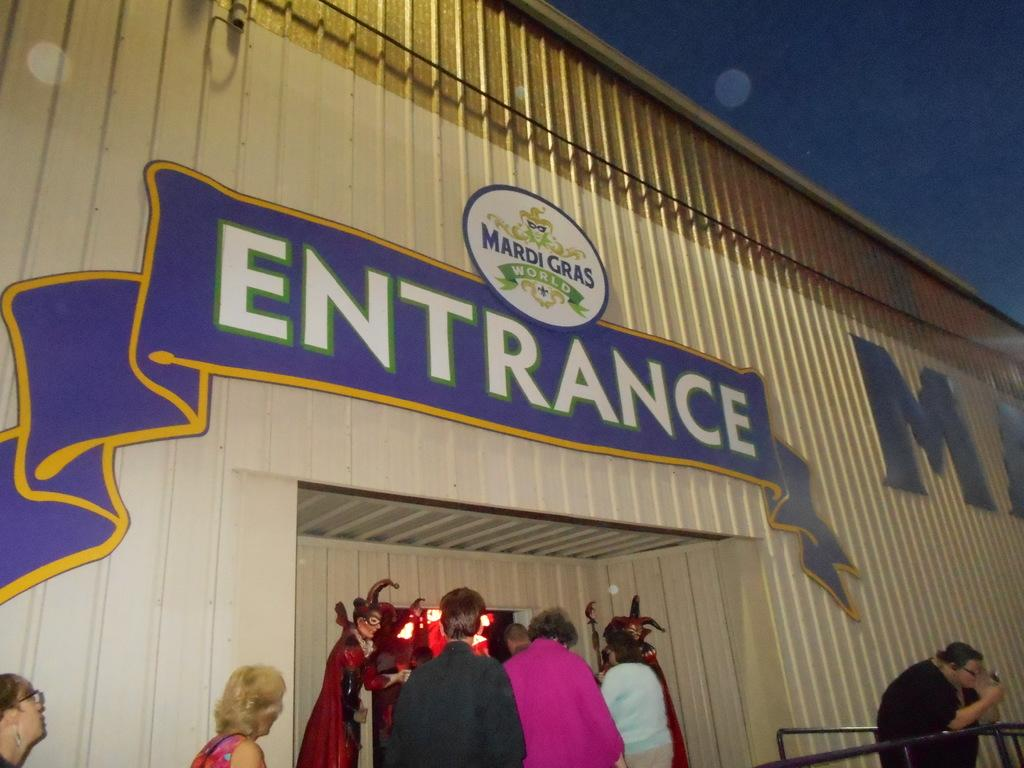<image>
Present a compact description of the photo's key features. a building with the word entrance on it 